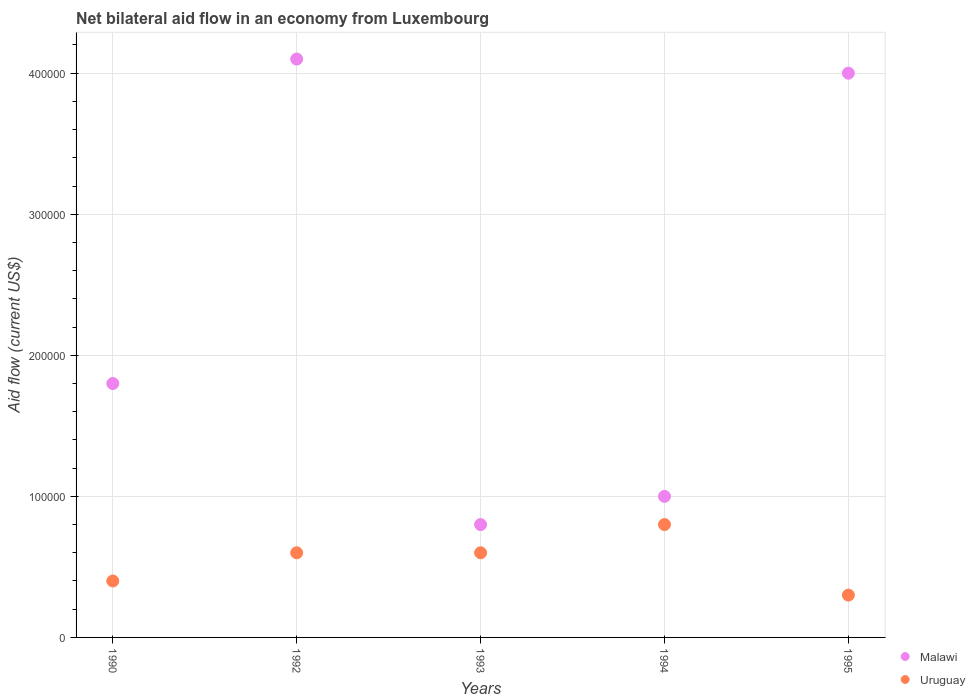How many different coloured dotlines are there?
Offer a very short reply. 2. Is the number of dotlines equal to the number of legend labels?
Your answer should be very brief. Yes. Across all years, what is the maximum net bilateral aid flow in Uruguay?
Your answer should be very brief. 8.00e+04. What is the total net bilateral aid flow in Malawi in the graph?
Provide a short and direct response. 1.17e+06. What is the difference between the net bilateral aid flow in Uruguay in 1995 and the net bilateral aid flow in Malawi in 1990?
Your response must be concise. -1.50e+05. What is the average net bilateral aid flow in Uruguay per year?
Your answer should be compact. 5.40e+04. In how many years, is the net bilateral aid flow in Uruguay greater than 260000 US$?
Offer a very short reply. 0. Is the net bilateral aid flow in Malawi in 1990 less than that in 1993?
Provide a short and direct response. No. What is the difference between the highest and the lowest net bilateral aid flow in Malawi?
Give a very brief answer. 3.30e+05. Is the sum of the net bilateral aid flow in Malawi in 1994 and 1995 greater than the maximum net bilateral aid flow in Uruguay across all years?
Make the answer very short. Yes. Does the net bilateral aid flow in Malawi monotonically increase over the years?
Offer a terse response. No. Is the net bilateral aid flow in Malawi strictly less than the net bilateral aid flow in Uruguay over the years?
Offer a terse response. No. How many years are there in the graph?
Give a very brief answer. 5. Does the graph contain any zero values?
Provide a succinct answer. No. Where does the legend appear in the graph?
Keep it short and to the point. Bottom right. What is the title of the graph?
Make the answer very short. Net bilateral aid flow in an economy from Luxembourg. Does "Monaco" appear as one of the legend labels in the graph?
Provide a short and direct response. No. What is the Aid flow (current US$) in Malawi in 1990?
Give a very brief answer. 1.80e+05. What is the Aid flow (current US$) in Uruguay in 1992?
Provide a short and direct response. 6.00e+04. What is the Aid flow (current US$) in Malawi in 1993?
Provide a short and direct response. 8.00e+04. What is the Aid flow (current US$) of Uruguay in 1993?
Provide a succinct answer. 6.00e+04. What is the Aid flow (current US$) in Malawi in 1994?
Make the answer very short. 1.00e+05. What is the Aid flow (current US$) in Uruguay in 1994?
Provide a short and direct response. 8.00e+04. Across all years, what is the minimum Aid flow (current US$) of Malawi?
Ensure brevity in your answer.  8.00e+04. What is the total Aid flow (current US$) of Malawi in the graph?
Your response must be concise. 1.17e+06. What is the difference between the Aid flow (current US$) of Malawi in 1990 and that in 1993?
Your answer should be very brief. 1.00e+05. What is the difference between the Aid flow (current US$) of Uruguay in 1992 and that in 1995?
Keep it short and to the point. 3.00e+04. What is the difference between the Aid flow (current US$) in Malawi in 1993 and that in 1994?
Provide a succinct answer. -2.00e+04. What is the difference between the Aid flow (current US$) of Uruguay in 1993 and that in 1994?
Your answer should be very brief. -2.00e+04. What is the difference between the Aid flow (current US$) in Malawi in 1993 and that in 1995?
Provide a short and direct response. -3.20e+05. What is the difference between the Aid flow (current US$) of Uruguay in 1993 and that in 1995?
Offer a terse response. 3.00e+04. What is the difference between the Aid flow (current US$) in Malawi in 1990 and the Aid flow (current US$) in Uruguay in 1992?
Your answer should be very brief. 1.20e+05. What is the difference between the Aid flow (current US$) in Malawi in 1990 and the Aid flow (current US$) in Uruguay in 1993?
Keep it short and to the point. 1.20e+05. What is the difference between the Aid flow (current US$) of Malawi in 1993 and the Aid flow (current US$) of Uruguay in 1995?
Your response must be concise. 5.00e+04. What is the difference between the Aid flow (current US$) of Malawi in 1994 and the Aid flow (current US$) of Uruguay in 1995?
Your response must be concise. 7.00e+04. What is the average Aid flow (current US$) in Malawi per year?
Your response must be concise. 2.34e+05. What is the average Aid flow (current US$) in Uruguay per year?
Offer a terse response. 5.40e+04. In the year 1990, what is the difference between the Aid flow (current US$) in Malawi and Aid flow (current US$) in Uruguay?
Your answer should be very brief. 1.40e+05. In the year 1993, what is the difference between the Aid flow (current US$) of Malawi and Aid flow (current US$) of Uruguay?
Provide a short and direct response. 2.00e+04. In the year 1994, what is the difference between the Aid flow (current US$) in Malawi and Aid flow (current US$) in Uruguay?
Ensure brevity in your answer.  2.00e+04. In the year 1995, what is the difference between the Aid flow (current US$) in Malawi and Aid flow (current US$) in Uruguay?
Your response must be concise. 3.70e+05. What is the ratio of the Aid flow (current US$) of Malawi in 1990 to that in 1992?
Provide a short and direct response. 0.44. What is the ratio of the Aid flow (current US$) of Uruguay in 1990 to that in 1992?
Offer a very short reply. 0.67. What is the ratio of the Aid flow (current US$) of Malawi in 1990 to that in 1993?
Give a very brief answer. 2.25. What is the ratio of the Aid flow (current US$) in Malawi in 1990 to that in 1994?
Offer a very short reply. 1.8. What is the ratio of the Aid flow (current US$) of Malawi in 1990 to that in 1995?
Give a very brief answer. 0.45. What is the ratio of the Aid flow (current US$) of Malawi in 1992 to that in 1993?
Your answer should be compact. 5.12. What is the ratio of the Aid flow (current US$) in Uruguay in 1992 to that in 1993?
Ensure brevity in your answer.  1. What is the ratio of the Aid flow (current US$) of Malawi in 1992 to that in 1995?
Provide a short and direct response. 1.02. What is the ratio of the Aid flow (current US$) in Uruguay in 1993 to that in 1994?
Provide a short and direct response. 0.75. What is the ratio of the Aid flow (current US$) of Malawi in 1993 to that in 1995?
Your answer should be very brief. 0.2. What is the ratio of the Aid flow (current US$) in Malawi in 1994 to that in 1995?
Provide a short and direct response. 0.25. What is the ratio of the Aid flow (current US$) of Uruguay in 1994 to that in 1995?
Your response must be concise. 2.67. What is the difference between the highest and the second highest Aid flow (current US$) of Malawi?
Offer a terse response. 10000. What is the difference between the highest and the lowest Aid flow (current US$) in Malawi?
Ensure brevity in your answer.  3.30e+05. 